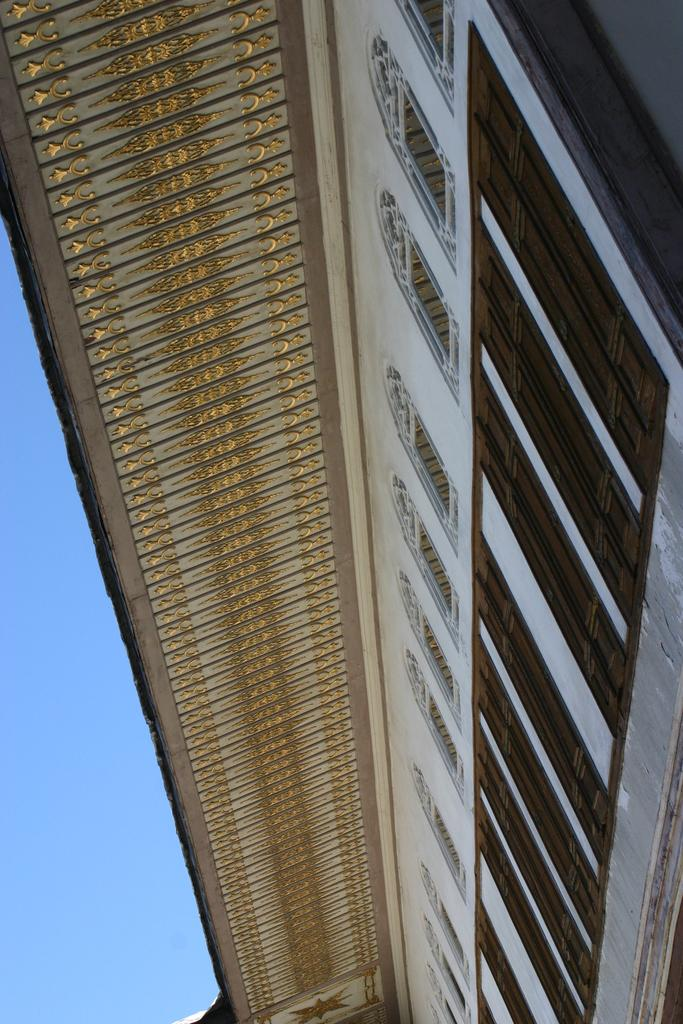What type of structure is present in the image? There is a building in the image. What can be seen in the background of the image? The sky is visible in the background of the image. How many goldfish are swimming in the building in the image? There are no goldfish present in the image; it features a building and the sky. 